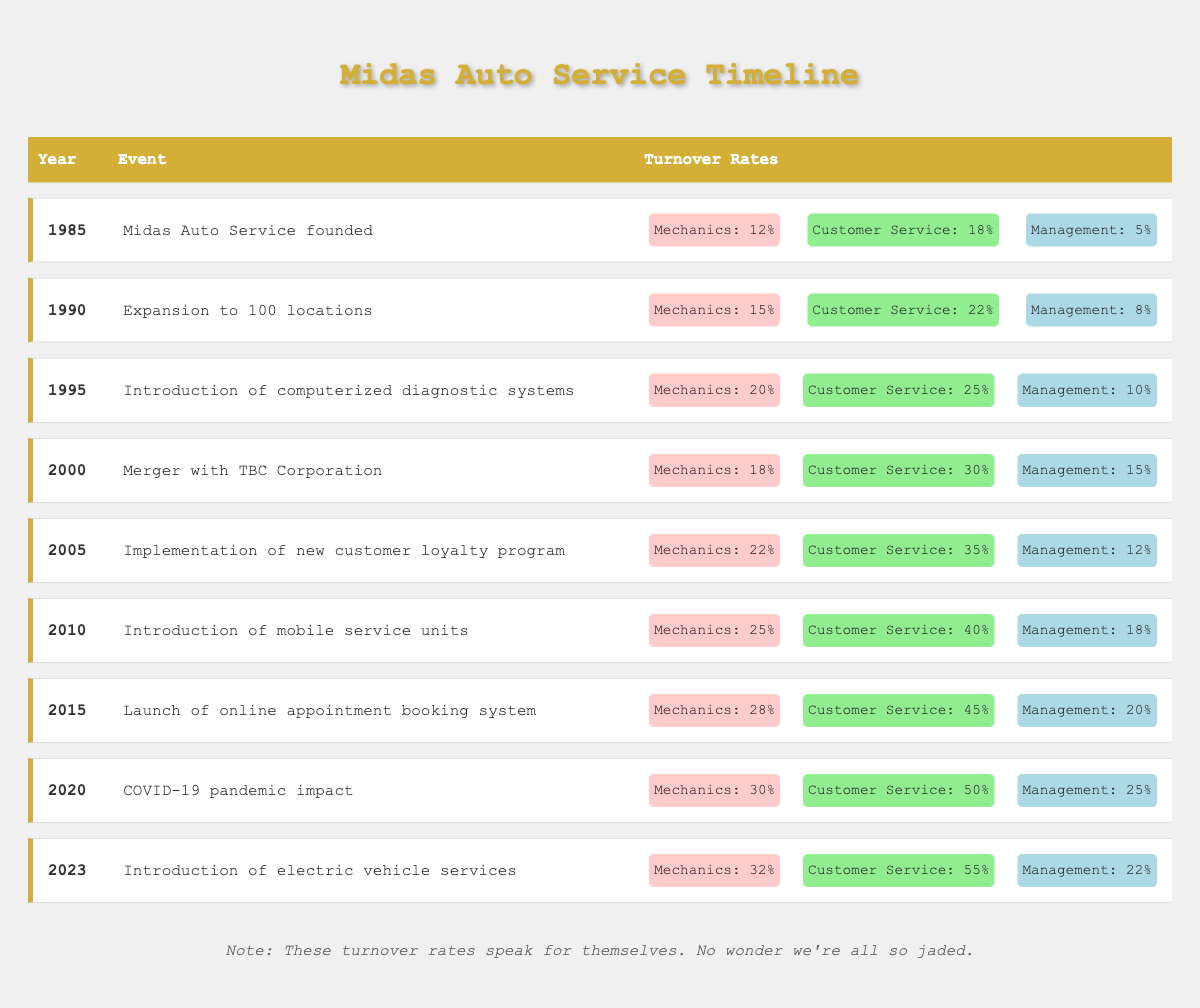What was the turnover rate for mechanics in 1995? The table shows the data for the year 1995, where the turnover rate for mechanics is listed as 20%.
Answer: 20% Which department had the highest turnover rate in 2023? In the year 2023, the turnover rates for mechanics, customer service, and management are 32%, 55%, and 22% respectively. Comparing these, customer service had the highest turnover rate.
Answer: Customer service What is the difference in turnover rates for customer service between 2010 and 2015? The turnover rate for customer service in 2010 is 40%, and in 2015 it is 45%. The difference can be calculated as 45% - 40% = 5%.
Answer: 5% Was the turnover rate for management ever higher than 15%? By examining the data, the turnover rates for management are 18% in 2010, 20% in 2015, and 25% in 2020. This means that it was indeed higher than 15% in those years.
Answer: Yes What was the average turnover rate for mechanics from 2000 to 2023? The turnover rates for mechanics from 2000 to 2023 are: 18% (2000), 22% (2005), 25% (2010), 28% (2015), 30% (2020), and 32% (2023). Summing these rates gives 18 + 22 + 25 + 28 + 30 + 32 = 155. As there are 6 data points, the average is calculated as 155 / 6 = approximately 25.83%.
Answer: Approximately 25.83% How have the turnover rates for mechanics changed from 1985 to 2023? In 1985, the turnover rate for mechanics was 12%, and in 2023 it increased to 32%. The change can be expressed as a difference: 32% - 12% = 20%, indicating a significant increase over 38 years.
Answer: Increased by 20% 